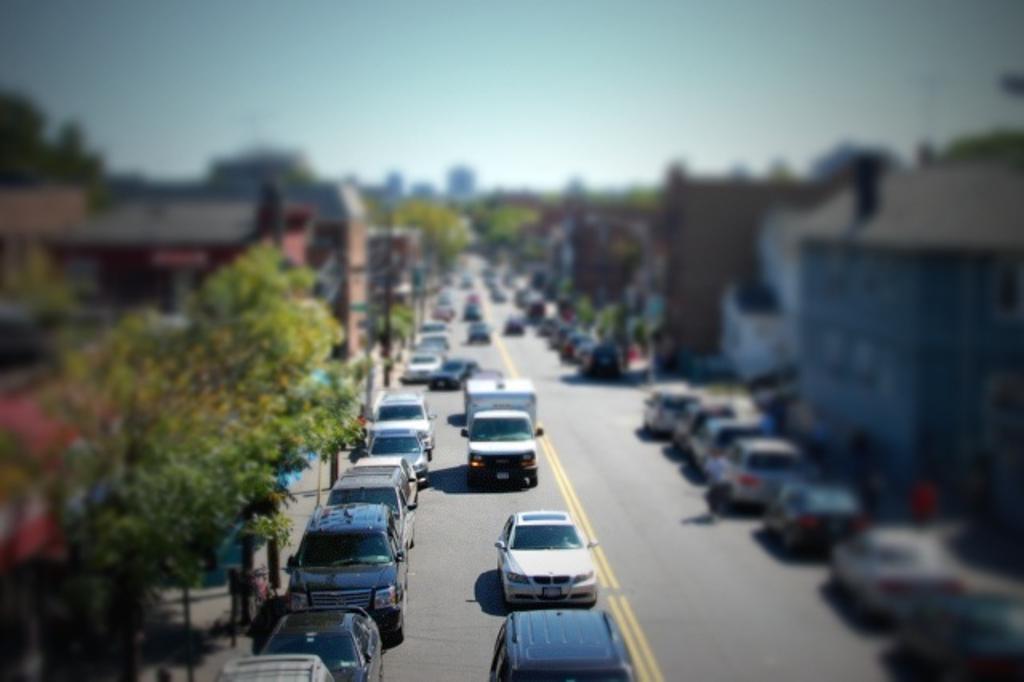How would you summarize this image in a sentence or two? This picture is clicked outside the city. At the bottom of the picture, we see vehicles moving on the road. On either side of the road, We see trees, buildings and street lights. At the top of the picture, we see the sky. In the background, it is blurred. 